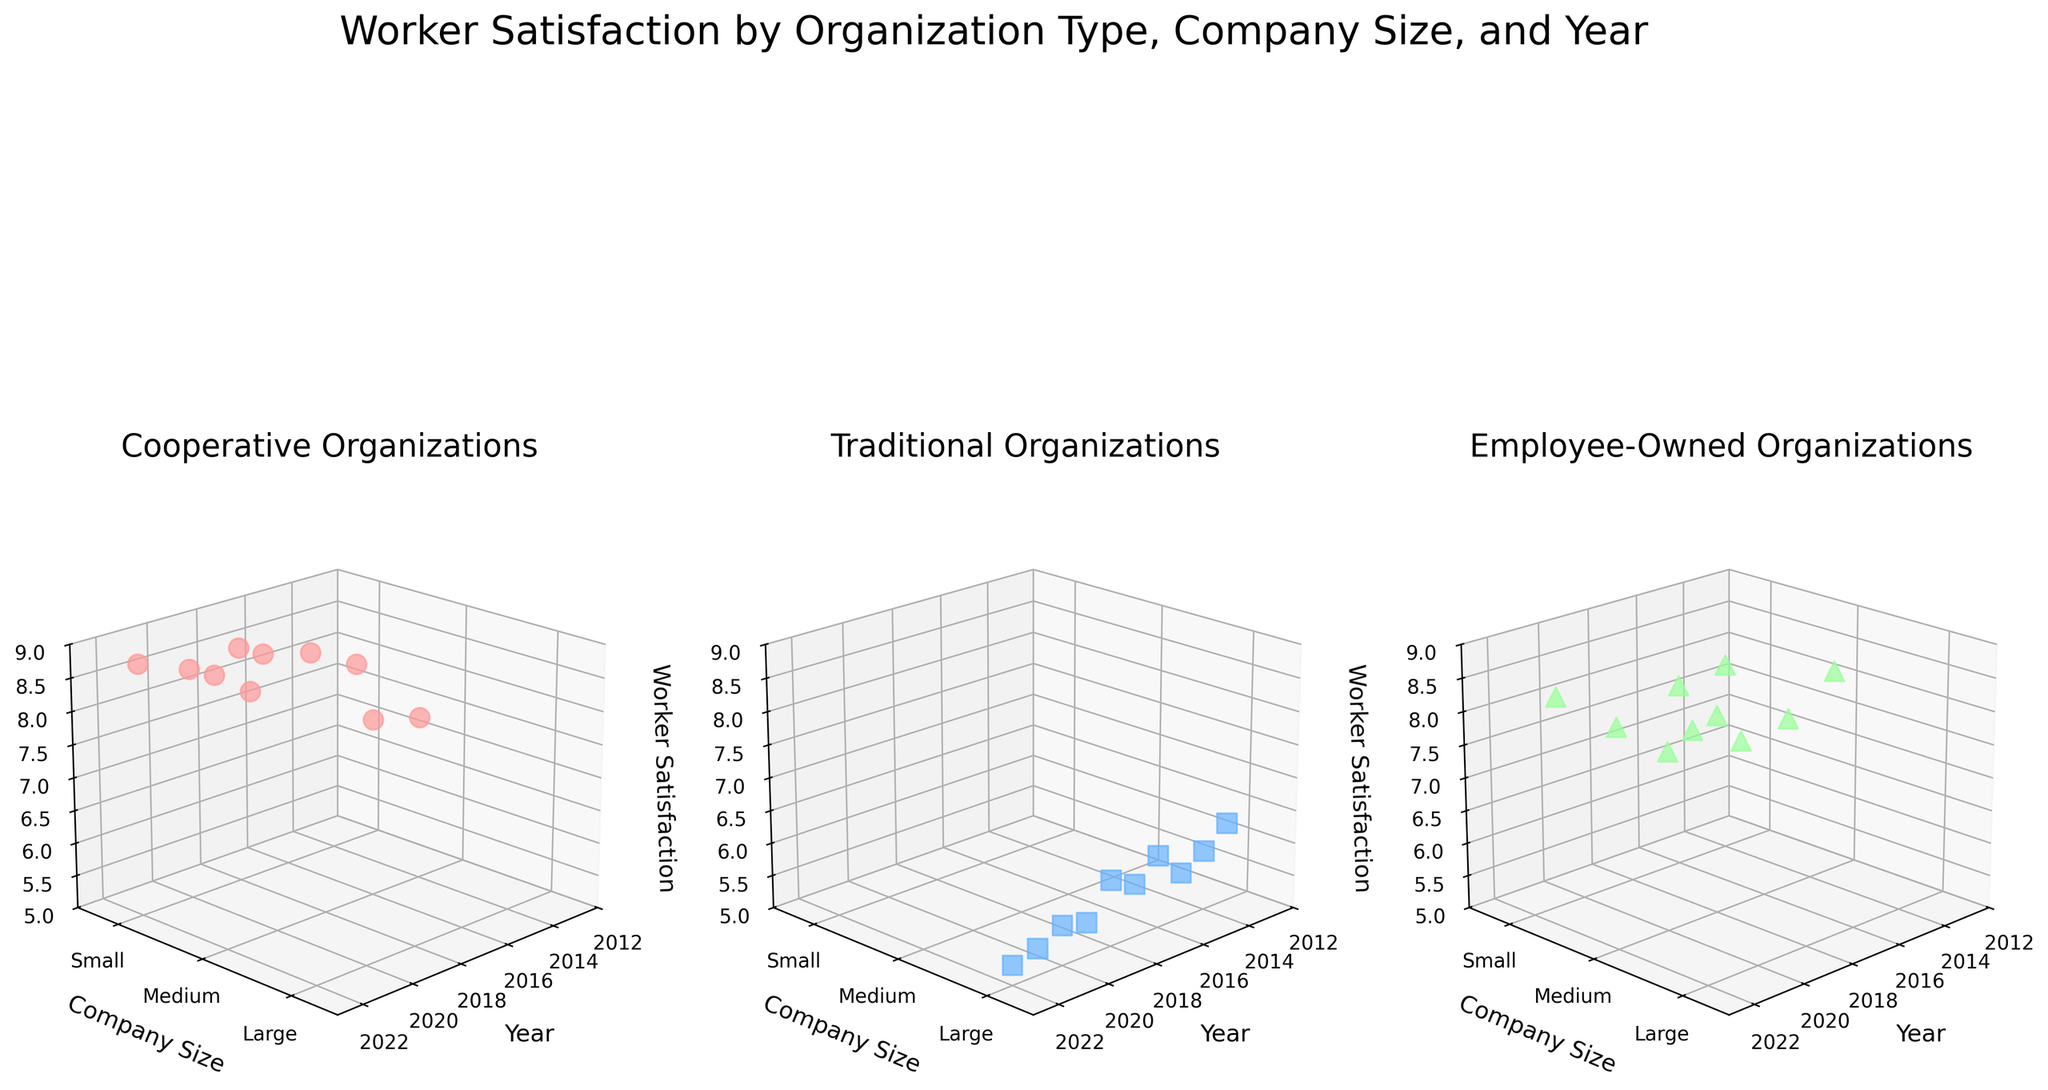Which organization type has the highest worker satisfaction scores in the figure? By examining the scatter plots for each organization type, we see that the Cooperative organization type consistently has the highest worker satisfaction scores, particularly evident with scores around 8.8.
Answer: Cooperative How does worker satisfaction in traditional organizations change from 2013 to 2022? In the Traditional organization type subplot, worker satisfaction declines over the years, from a high of 6.2 in 2013 to a low of 5.3 in 2022.
Answer: Decreases Which company size typically shows the highest worker satisfaction in employee-owned organizations? In the Employee-Owned organization type subplot, small and medium company sizes frequently show higher satisfaction compared to large ones. This is evident with scores often trending above 8.0.
Answer: Small and Medium How does worker satisfaction in Cooperative organizations for small companies change between 2019 and 2022? For Cooperative organizations with small companies, worker satisfaction moves from 8.3 in 2019 to 8.8 in 2022, indicating an increasing trend.
Answer: Increases Which year showed the lowest worker satisfaction in Traditional organizations? By looking at the lowest points in the Traditional organization type subplot, 2022 shows the lowest worker satisfaction with a score of 5.3.
Answer: 2022 Comparing 2013 and 2015, which organization type had a greater increase in worker satisfaction? In 2013, Cooperative satisfaction was 7.8; in 2015, it was 8.2 (increase of 0.4). Traditional satisfaction was 6.2 in 2013 and 5.7 in 2015 (decrease of 0.5). Employee-Owned was 8.1 in 2013 and 7.6 in 2015 (decrease of 0.5). Thus, Cooperative had the greatest increase.
Answer: Cooperative In which industry and organization type do we see the lowest worker satisfaction score? For the Traditional organization type, the industry with the lowest worker satisfaction is Mining, showing a score of 5.3 in 2022.
Answer: Mining, Traditional Are there any Large-sized Cooperative companies in the data set? By examining the Cooperative subplot, all data points show company sizes as Small or Medium; there are no Large-sized companies.
Answer: No What is the trend in worker satisfaction in Employee-Owned organizations involving small companies from 2016 to 2021? Analyzing the Employee-Owned subplot, from 2016 to 2021, worker satisfaction for small companies moves from 7.8 (2016) to 8.2 (2021), indicating an upward trend.
Answer: Increasing 